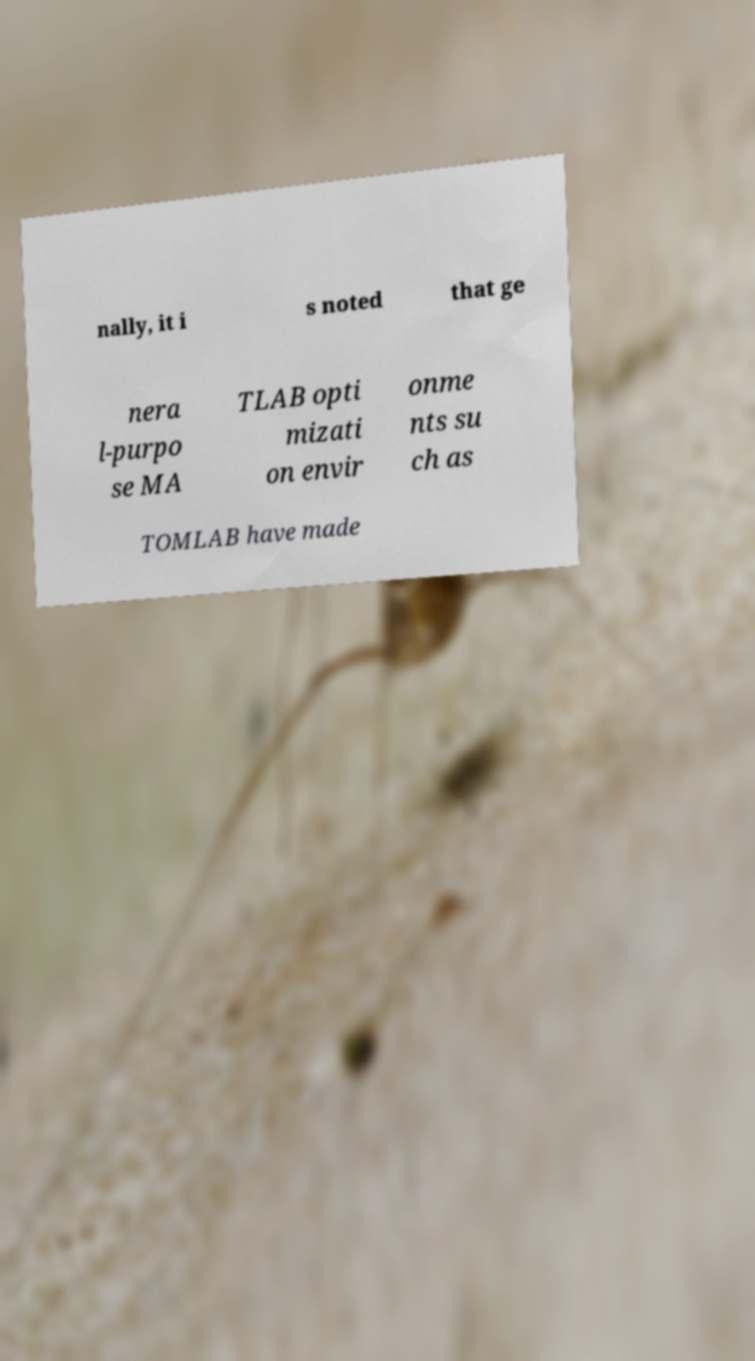For documentation purposes, I need the text within this image transcribed. Could you provide that? nally, it i s noted that ge nera l-purpo se MA TLAB opti mizati on envir onme nts su ch as TOMLAB have made 